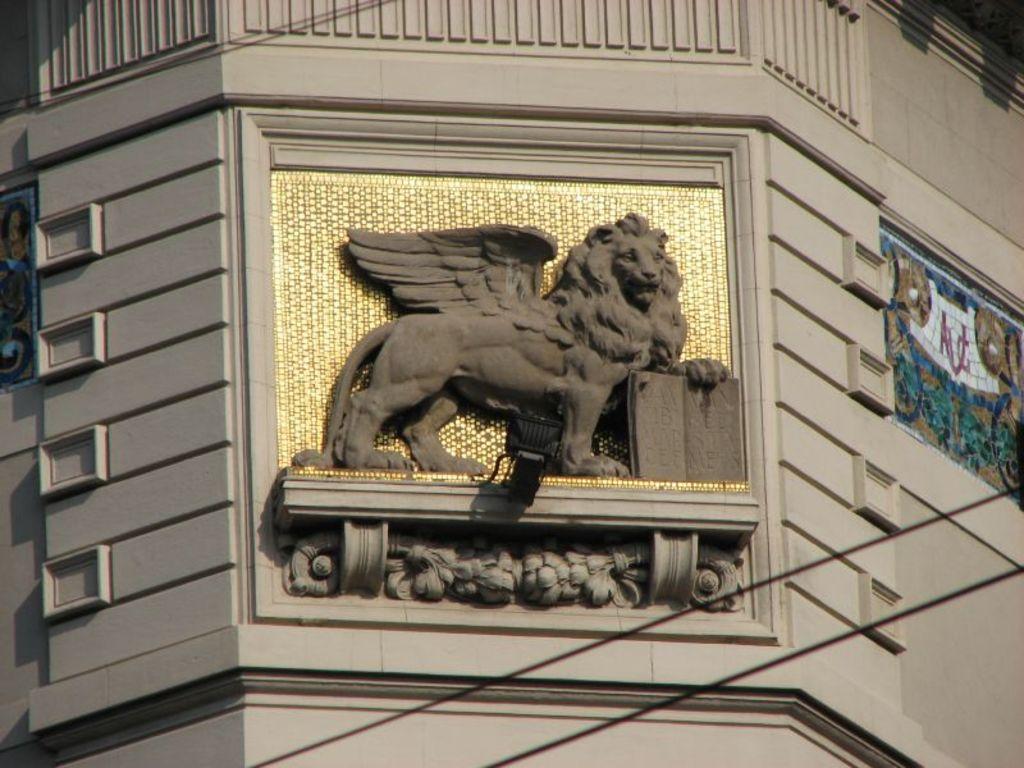Describe this image in one or two sentences. In the center of the image we can see a carving to the wall. In the background of the image we can see the painting and wall. 